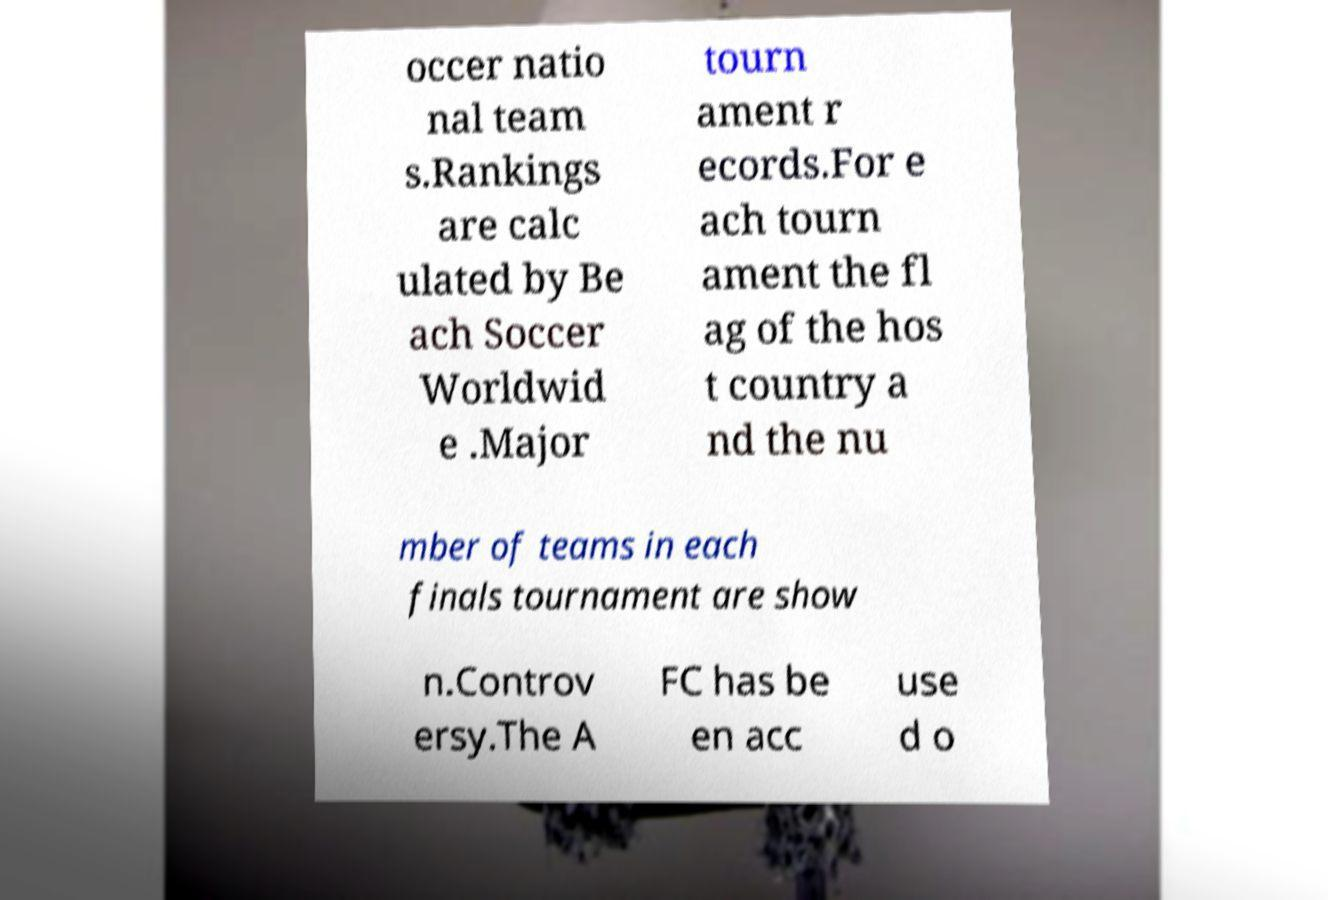I need the written content from this picture converted into text. Can you do that? occer natio nal team s.Rankings are calc ulated by Be ach Soccer Worldwid e .Major tourn ament r ecords.For e ach tourn ament the fl ag of the hos t country a nd the nu mber of teams in each finals tournament are show n.Controv ersy.The A FC has be en acc use d o 